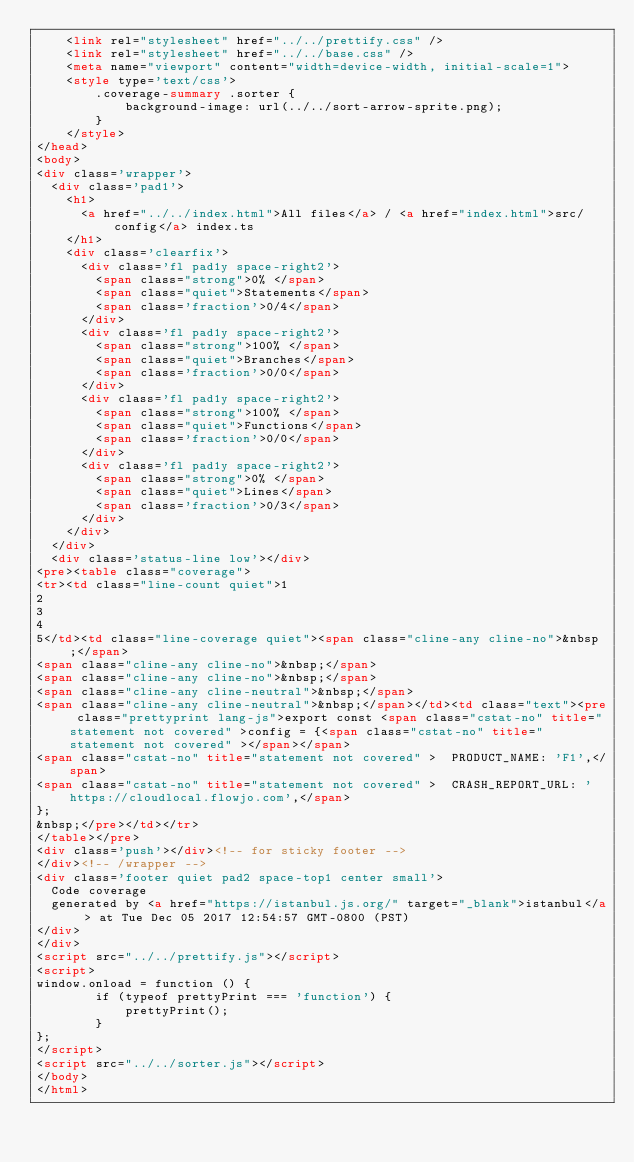Convert code to text. <code><loc_0><loc_0><loc_500><loc_500><_HTML_>    <link rel="stylesheet" href="../../prettify.css" />
    <link rel="stylesheet" href="../../base.css" />
    <meta name="viewport" content="width=device-width, initial-scale=1">
    <style type='text/css'>
        .coverage-summary .sorter {
            background-image: url(../../sort-arrow-sprite.png);
        }
    </style>
</head>
<body>
<div class='wrapper'>
  <div class='pad1'>
    <h1>
      <a href="../../index.html">All files</a> / <a href="index.html">src/config</a> index.ts
    </h1>
    <div class='clearfix'>
      <div class='fl pad1y space-right2'>
        <span class="strong">0% </span>
        <span class="quiet">Statements</span>
        <span class='fraction'>0/4</span>
      </div>
      <div class='fl pad1y space-right2'>
        <span class="strong">100% </span>
        <span class="quiet">Branches</span>
        <span class='fraction'>0/0</span>
      </div>
      <div class='fl pad1y space-right2'>
        <span class="strong">100% </span>
        <span class="quiet">Functions</span>
        <span class='fraction'>0/0</span>
      </div>
      <div class='fl pad1y space-right2'>
        <span class="strong">0% </span>
        <span class="quiet">Lines</span>
        <span class='fraction'>0/3</span>
      </div>
    </div>
  </div>
  <div class='status-line low'></div>
<pre><table class="coverage">
<tr><td class="line-count quiet">1
2
3
4
5</td><td class="line-coverage quiet"><span class="cline-any cline-no">&nbsp;</span>
<span class="cline-any cline-no">&nbsp;</span>
<span class="cline-any cline-no">&nbsp;</span>
<span class="cline-any cline-neutral">&nbsp;</span>
<span class="cline-any cline-neutral">&nbsp;</span></td><td class="text"><pre class="prettyprint lang-js">export const <span class="cstat-no" title="statement not covered" >config = {<span class="cstat-no" title="statement not covered" ></span></span>
<span class="cstat-no" title="statement not covered" >  PRODUCT_NAME: 'F1',</span>
<span class="cstat-no" title="statement not covered" >  CRASH_REPORT_URL: 'https://cloudlocal.flowjo.com',</span>
};
&nbsp;</pre></td></tr>
</table></pre>
<div class='push'></div><!-- for sticky footer -->
</div><!-- /wrapper -->
<div class='footer quiet pad2 space-top1 center small'>
  Code coverage
  generated by <a href="https://istanbul.js.org/" target="_blank">istanbul</a> at Tue Dec 05 2017 12:54:57 GMT-0800 (PST)
</div>
</div>
<script src="../../prettify.js"></script>
<script>
window.onload = function () {
        if (typeof prettyPrint === 'function') {
            prettyPrint();
        }
};
</script>
<script src="../../sorter.js"></script>
</body>
</html>
</code> 